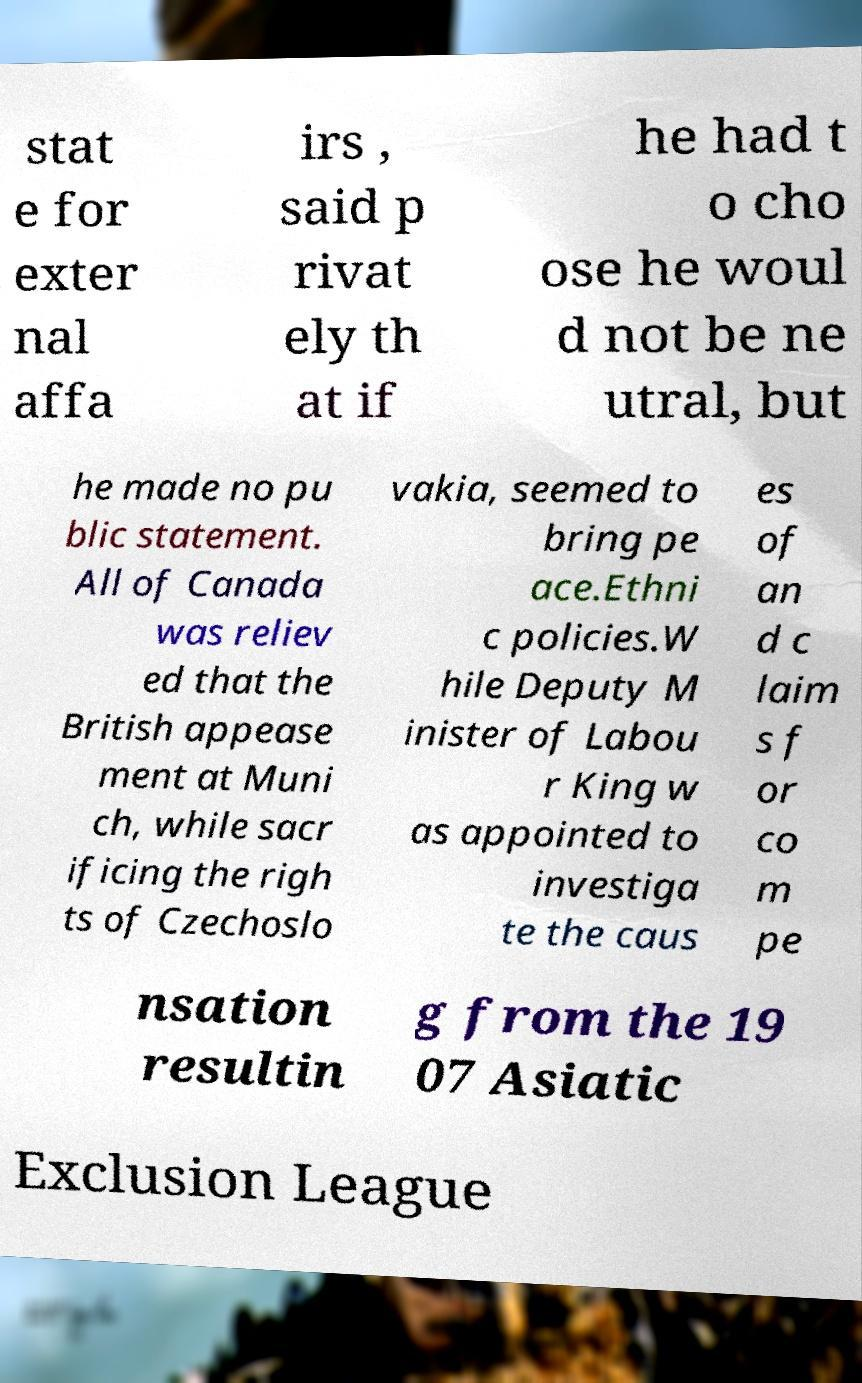Please read and relay the text visible in this image. What does it say? stat e for exter nal affa irs , said p rivat ely th at if he had t o cho ose he woul d not be ne utral, but he made no pu blic statement. All of Canada was reliev ed that the British appease ment at Muni ch, while sacr ificing the righ ts of Czechoslo vakia, seemed to bring pe ace.Ethni c policies.W hile Deputy M inister of Labou r King w as appointed to investiga te the caus es of an d c laim s f or co m pe nsation resultin g from the 19 07 Asiatic Exclusion League 